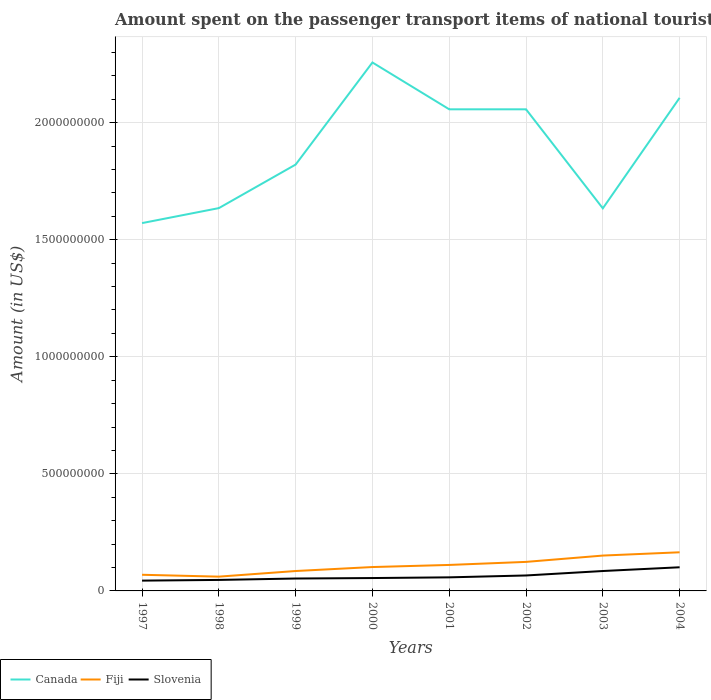How many different coloured lines are there?
Your answer should be very brief. 3. Does the line corresponding to Slovenia intersect with the line corresponding to Canada?
Ensure brevity in your answer.  No. Is the number of lines equal to the number of legend labels?
Give a very brief answer. Yes. Across all years, what is the maximum amount spent on the passenger transport items of national tourists in Canada?
Your response must be concise. 1.57e+09. What is the total amount spent on the passenger transport items of national tourists in Slovenia in the graph?
Provide a succinct answer. -4.30e+07. What is the difference between the highest and the second highest amount spent on the passenger transport items of national tourists in Slovenia?
Your response must be concise. 5.70e+07. What is the difference between the highest and the lowest amount spent on the passenger transport items of national tourists in Slovenia?
Provide a succinct answer. 3. Is the amount spent on the passenger transport items of national tourists in Canada strictly greater than the amount spent on the passenger transport items of national tourists in Fiji over the years?
Offer a very short reply. No. How many lines are there?
Offer a very short reply. 3. Are the values on the major ticks of Y-axis written in scientific E-notation?
Ensure brevity in your answer.  No. Where does the legend appear in the graph?
Offer a very short reply. Bottom left. How many legend labels are there?
Offer a very short reply. 3. What is the title of the graph?
Make the answer very short. Amount spent on the passenger transport items of national tourists. What is the label or title of the X-axis?
Give a very brief answer. Years. What is the Amount (in US$) in Canada in 1997?
Ensure brevity in your answer.  1.57e+09. What is the Amount (in US$) of Fiji in 1997?
Make the answer very short. 6.90e+07. What is the Amount (in US$) in Slovenia in 1997?
Offer a very short reply. 4.40e+07. What is the Amount (in US$) in Canada in 1998?
Your response must be concise. 1.64e+09. What is the Amount (in US$) in Fiji in 1998?
Give a very brief answer. 6.10e+07. What is the Amount (in US$) of Slovenia in 1998?
Give a very brief answer. 4.70e+07. What is the Amount (in US$) of Canada in 1999?
Make the answer very short. 1.82e+09. What is the Amount (in US$) of Fiji in 1999?
Your answer should be compact. 8.50e+07. What is the Amount (in US$) in Slovenia in 1999?
Offer a terse response. 5.30e+07. What is the Amount (in US$) in Canada in 2000?
Ensure brevity in your answer.  2.26e+09. What is the Amount (in US$) in Fiji in 2000?
Provide a short and direct response. 1.02e+08. What is the Amount (in US$) in Slovenia in 2000?
Provide a succinct answer. 5.50e+07. What is the Amount (in US$) in Canada in 2001?
Your answer should be compact. 2.06e+09. What is the Amount (in US$) in Fiji in 2001?
Your answer should be very brief. 1.11e+08. What is the Amount (in US$) in Slovenia in 2001?
Provide a short and direct response. 5.80e+07. What is the Amount (in US$) in Canada in 2002?
Provide a succinct answer. 2.06e+09. What is the Amount (in US$) of Fiji in 2002?
Your response must be concise. 1.24e+08. What is the Amount (in US$) in Slovenia in 2002?
Your answer should be compact. 6.60e+07. What is the Amount (in US$) of Canada in 2003?
Provide a short and direct response. 1.63e+09. What is the Amount (in US$) in Fiji in 2003?
Your answer should be compact. 1.51e+08. What is the Amount (in US$) in Slovenia in 2003?
Offer a very short reply. 8.50e+07. What is the Amount (in US$) in Canada in 2004?
Provide a succinct answer. 2.11e+09. What is the Amount (in US$) in Fiji in 2004?
Provide a short and direct response. 1.65e+08. What is the Amount (in US$) in Slovenia in 2004?
Offer a very short reply. 1.01e+08. Across all years, what is the maximum Amount (in US$) of Canada?
Keep it short and to the point. 2.26e+09. Across all years, what is the maximum Amount (in US$) of Fiji?
Ensure brevity in your answer.  1.65e+08. Across all years, what is the maximum Amount (in US$) in Slovenia?
Your answer should be very brief. 1.01e+08. Across all years, what is the minimum Amount (in US$) in Canada?
Provide a short and direct response. 1.57e+09. Across all years, what is the minimum Amount (in US$) of Fiji?
Offer a terse response. 6.10e+07. Across all years, what is the minimum Amount (in US$) in Slovenia?
Offer a terse response. 4.40e+07. What is the total Amount (in US$) of Canada in the graph?
Provide a short and direct response. 1.51e+1. What is the total Amount (in US$) in Fiji in the graph?
Provide a short and direct response. 8.68e+08. What is the total Amount (in US$) in Slovenia in the graph?
Offer a terse response. 5.09e+08. What is the difference between the Amount (in US$) of Canada in 1997 and that in 1998?
Offer a terse response. -6.40e+07. What is the difference between the Amount (in US$) of Fiji in 1997 and that in 1998?
Provide a short and direct response. 8.00e+06. What is the difference between the Amount (in US$) of Canada in 1997 and that in 1999?
Provide a short and direct response. -2.50e+08. What is the difference between the Amount (in US$) in Fiji in 1997 and that in 1999?
Your answer should be very brief. -1.60e+07. What is the difference between the Amount (in US$) in Slovenia in 1997 and that in 1999?
Offer a very short reply. -9.00e+06. What is the difference between the Amount (in US$) in Canada in 1997 and that in 2000?
Your response must be concise. -6.86e+08. What is the difference between the Amount (in US$) of Fiji in 1997 and that in 2000?
Make the answer very short. -3.30e+07. What is the difference between the Amount (in US$) in Slovenia in 1997 and that in 2000?
Your answer should be compact. -1.10e+07. What is the difference between the Amount (in US$) in Canada in 1997 and that in 2001?
Keep it short and to the point. -4.86e+08. What is the difference between the Amount (in US$) in Fiji in 1997 and that in 2001?
Your answer should be compact. -4.20e+07. What is the difference between the Amount (in US$) in Slovenia in 1997 and that in 2001?
Make the answer very short. -1.40e+07. What is the difference between the Amount (in US$) of Canada in 1997 and that in 2002?
Your answer should be compact. -4.86e+08. What is the difference between the Amount (in US$) of Fiji in 1997 and that in 2002?
Offer a terse response. -5.50e+07. What is the difference between the Amount (in US$) of Slovenia in 1997 and that in 2002?
Make the answer very short. -2.20e+07. What is the difference between the Amount (in US$) in Canada in 1997 and that in 2003?
Offer a very short reply. -6.30e+07. What is the difference between the Amount (in US$) in Fiji in 1997 and that in 2003?
Offer a terse response. -8.20e+07. What is the difference between the Amount (in US$) of Slovenia in 1997 and that in 2003?
Offer a terse response. -4.10e+07. What is the difference between the Amount (in US$) of Canada in 1997 and that in 2004?
Make the answer very short. -5.35e+08. What is the difference between the Amount (in US$) in Fiji in 1997 and that in 2004?
Make the answer very short. -9.60e+07. What is the difference between the Amount (in US$) of Slovenia in 1997 and that in 2004?
Give a very brief answer. -5.70e+07. What is the difference between the Amount (in US$) in Canada in 1998 and that in 1999?
Provide a succinct answer. -1.86e+08. What is the difference between the Amount (in US$) in Fiji in 1998 and that in 1999?
Your response must be concise. -2.40e+07. What is the difference between the Amount (in US$) in Slovenia in 1998 and that in 1999?
Your answer should be very brief. -6.00e+06. What is the difference between the Amount (in US$) in Canada in 1998 and that in 2000?
Your answer should be compact. -6.22e+08. What is the difference between the Amount (in US$) of Fiji in 1998 and that in 2000?
Your answer should be very brief. -4.10e+07. What is the difference between the Amount (in US$) in Slovenia in 1998 and that in 2000?
Offer a terse response. -8.00e+06. What is the difference between the Amount (in US$) in Canada in 1998 and that in 2001?
Your answer should be compact. -4.22e+08. What is the difference between the Amount (in US$) in Fiji in 1998 and that in 2001?
Provide a succinct answer. -5.00e+07. What is the difference between the Amount (in US$) of Slovenia in 1998 and that in 2001?
Offer a very short reply. -1.10e+07. What is the difference between the Amount (in US$) of Canada in 1998 and that in 2002?
Keep it short and to the point. -4.22e+08. What is the difference between the Amount (in US$) in Fiji in 1998 and that in 2002?
Make the answer very short. -6.30e+07. What is the difference between the Amount (in US$) of Slovenia in 1998 and that in 2002?
Ensure brevity in your answer.  -1.90e+07. What is the difference between the Amount (in US$) of Fiji in 1998 and that in 2003?
Offer a terse response. -9.00e+07. What is the difference between the Amount (in US$) in Slovenia in 1998 and that in 2003?
Your answer should be compact. -3.80e+07. What is the difference between the Amount (in US$) in Canada in 1998 and that in 2004?
Provide a short and direct response. -4.71e+08. What is the difference between the Amount (in US$) in Fiji in 1998 and that in 2004?
Your answer should be very brief. -1.04e+08. What is the difference between the Amount (in US$) in Slovenia in 1998 and that in 2004?
Provide a succinct answer. -5.40e+07. What is the difference between the Amount (in US$) in Canada in 1999 and that in 2000?
Ensure brevity in your answer.  -4.36e+08. What is the difference between the Amount (in US$) of Fiji in 1999 and that in 2000?
Offer a terse response. -1.70e+07. What is the difference between the Amount (in US$) in Canada in 1999 and that in 2001?
Provide a short and direct response. -2.36e+08. What is the difference between the Amount (in US$) in Fiji in 1999 and that in 2001?
Your answer should be very brief. -2.60e+07. What is the difference between the Amount (in US$) of Slovenia in 1999 and that in 2001?
Your answer should be very brief. -5.00e+06. What is the difference between the Amount (in US$) in Canada in 1999 and that in 2002?
Offer a terse response. -2.36e+08. What is the difference between the Amount (in US$) in Fiji in 1999 and that in 2002?
Provide a succinct answer. -3.90e+07. What is the difference between the Amount (in US$) of Slovenia in 1999 and that in 2002?
Your answer should be compact. -1.30e+07. What is the difference between the Amount (in US$) in Canada in 1999 and that in 2003?
Keep it short and to the point. 1.87e+08. What is the difference between the Amount (in US$) in Fiji in 1999 and that in 2003?
Provide a succinct answer. -6.60e+07. What is the difference between the Amount (in US$) in Slovenia in 1999 and that in 2003?
Your answer should be very brief. -3.20e+07. What is the difference between the Amount (in US$) of Canada in 1999 and that in 2004?
Make the answer very short. -2.85e+08. What is the difference between the Amount (in US$) of Fiji in 1999 and that in 2004?
Give a very brief answer. -8.00e+07. What is the difference between the Amount (in US$) of Slovenia in 1999 and that in 2004?
Offer a very short reply. -4.80e+07. What is the difference between the Amount (in US$) in Canada in 2000 and that in 2001?
Provide a succinct answer. 2.00e+08. What is the difference between the Amount (in US$) in Fiji in 2000 and that in 2001?
Your answer should be very brief. -9.00e+06. What is the difference between the Amount (in US$) in Fiji in 2000 and that in 2002?
Keep it short and to the point. -2.20e+07. What is the difference between the Amount (in US$) in Slovenia in 2000 and that in 2002?
Provide a short and direct response. -1.10e+07. What is the difference between the Amount (in US$) in Canada in 2000 and that in 2003?
Provide a short and direct response. 6.23e+08. What is the difference between the Amount (in US$) in Fiji in 2000 and that in 2003?
Offer a terse response. -4.90e+07. What is the difference between the Amount (in US$) in Slovenia in 2000 and that in 2003?
Offer a very short reply. -3.00e+07. What is the difference between the Amount (in US$) of Canada in 2000 and that in 2004?
Offer a terse response. 1.51e+08. What is the difference between the Amount (in US$) of Fiji in 2000 and that in 2004?
Offer a terse response. -6.30e+07. What is the difference between the Amount (in US$) in Slovenia in 2000 and that in 2004?
Make the answer very short. -4.60e+07. What is the difference between the Amount (in US$) of Canada in 2001 and that in 2002?
Your answer should be compact. 0. What is the difference between the Amount (in US$) of Fiji in 2001 and that in 2002?
Keep it short and to the point. -1.30e+07. What is the difference between the Amount (in US$) in Slovenia in 2001 and that in 2002?
Make the answer very short. -8.00e+06. What is the difference between the Amount (in US$) in Canada in 2001 and that in 2003?
Offer a terse response. 4.23e+08. What is the difference between the Amount (in US$) in Fiji in 2001 and that in 2003?
Provide a short and direct response. -4.00e+07. What is the difference between the Amount (in US$) in Slovenia in 2001 and that in 2003?
Provide a succinct answer. -2.70e+07. What is the difference between the Amount (in US$) in Canada in 2001 and that in 2004?
Make the answer very short. -4.90e+07. What is the difference between the Amount (in US$) of Fiji in 2001 and that in 2004?
Your answer should be compact. -5.40e+07. What is the difference between the Amount (in US$) of Slovenia in 2001 and that in 2004?
Ensure brevity in your answer.  -4.30e+07. What is the difference between the Amount (in US$) of Canada in 2002 and that in 2003?
Give a very brief answer. 4.23e+08. What is the difference between the Amount (in US$) in Fiji in 2002 and that in 2003?
Give a very brief answer. -2.70e+07. What is the difference between the Amount (in US$) in Slovenia in 2002 and that in 2003?
Ensure brevity in your answer.  -1.90e+07. What is the difference between the Amount (in US$) of Canada in 2002 and that in 2004?
Offer a very short reply. -4.90e+07. What is the difference between the Amount (in US$) in Fiji in 2002 and that in 2004?
Offer a very short reply. -4.10e+07. What is the difference between the Amount (in US$) of Slovenia in 2002 and that in 2004?
Keep it short and to the point. -3.50e+07. What is the difference between the Amount (in US$) in Canada in 2003 and that in 2004?
Ensure brevity in your answer.  -4.72e+08. What is the difference between the Amount (in US$) in Fiji in 2003 and that in 2004?
Your response must be concise. -1.40e+07. What is the difference between the Amount (in US$) in Slovenia in 2003 and that in 2004?
Give a very brief answer. -1.60e+07. What is the difference between the Amount (in US$) in Canada in 1997 and the Amount (in US$) in Fiji in 1998?
Offer a terse response. 1.51e+09. What is the difference between the Amount (in US$) of Canada in 1997 and the Amount (in US$) of Slovenia in 1998?
Provide a succinct answer. 1.52e+09. What is the difference between the Amount (in US$) of Fiji in 1997 and the Amount (in US$) of Slovenia in 1998?
Your response must be concise. 2.20e+07. What is the difference between the Amount (in US$) of Canada in 1997 and the Amount (in US$) of Fiji in 1999?
Ensure brevity in your answer.  1.49e+09. What is the difference between the Amount (in US$) of Canada in 1997 and the Amount (in US$) of Slovenia in 1999?
Give a very brief answer. 1.52e+09. What is the difference between the Amount (in US$) in Fiji in 1997 and the Amount (in US$) in Slovenia in 1999?
Make the answer very short. 1.60e+07. What is the difference between the Amount (in US$) in Canada in 1997 and the Amount (in US$) in Fiji in 2000?
Make the answer very short. 1.47e+09. What is the difference between the Amount (in US$) of Canada in 1997 and the Amount (in US$) of Slovenia in 2000?
Ensure brevity in your answer.  1.52e+09. What is the difference between the Amount (in US$) of Fiji in 1997 and the Amount (in US$) of Slovenia in 2000?
Provide a short and direct response. 1.40e+07. What is the difference between the Amount (in US$) of Canada in 1997 and the Amount (in US$) of Fiji in 2001?
Keep it short and to the point. 1.46e+09. What is the difference between the Amount (in US$) in Canada in 1997 and the Amount (in US$) in Slovenia in 2001?
Offer a terse response. 1.51e+09. What is the difference between the Amount (in US$) of Fiji in 1997 and the Amount (in US$) of Slovenia in 2001?
Offer a very short reply. 1.10e+07. What is the difference between the Amount (in US$) in Canada in 1997 and the Amount (in US$) in Fiji in 2002?
Offer a very short reply. 1.45e+09. What is the difference between the Amount (in US$) in Canada in 1997 and the Amount (in US$) in Slovenia in 2002?
Your answer should be very brief. 1.50e+09. What is the difference between the Amount (in US$) of Fiji in 1997 and the Amount (in US$) of Slovenia in 2002?
Make the answer very short. 3.00e+06. What is the difference between the Amount (in US$) in Canada in 1997 and the Amount (in US$) in Fiji in 2003?
Provide a short and direct response. 1.42e+09. What is the difference between the Amount (in US$) of Canada in 1997 and the Amount (in US$) of Slovenia in 2003?
Provide a short and direct response. 1.49e+09. What is the difference between the Amount (in US$) of Fiji in 1997 and the Amount (in US$) of Slovenia in 2003?
Your response must be concise. -1.60e+07. What is the difference between the Amount (in US$) of Canada in 1997 and the Amount (in US$) of Fiji in 2004?
Ensure brevity in your answer.  1.41e+09. What is the difference between the Amount (in US$) of Canada in 1997 and the Amount (in US$) of Slovenia in 2004?
Your answer should be compact. 1.47e+09. What is the difference between the Amount (in US$) in Fiji in 1997 and the Amount (in US$) in Slovenia in 2004?
Make the answer very short. -3.20e+07. What is the difference between the Amount (in US$) of Canada in 1998 and the Amount (in US$) of Fiji in 1999?
Provide a succinct answer. 1.55e+09. What is the difference between the Amount (in US$) in Canada in 1998 and the Amount (in US$) in Slovenia in 1999?
Give a very brief answer. 1.58e+09. What is the difference between the Amount (in US$) of Fiji in 1998 and the Amount (in US$) of Slovenia in 1999?
Your response must be concise. 8.00e+06. What is the difference between the Amount (in US$) in Canada in 1998 and the Amount (in US$) in Fiji in 2000?
Ensure brevity in your answer.  1.53e+09. What is the difference between the Amount (in US$) in Canada in 1998 and the Amount (in US$) in Slovenia in 2000?
Your answer should be very brief. 1.58e+09. What is the difference between the Amount (in US$) in Canada in 1998 and the Amount (in US$) in Fiji in 2001?
Your response must be concise. 1.52e+09. What is the difference between the Amount (in US$) in Canada in 1998 and the Amount (in US$) in Slovenia in 2001?
Provide a short and direct response. 1.58e+09. What is the difference between the Amount (in US$) of Canada in 1998 and the Amount (in US$) of Fiji in 2002?
Your response must be concise. 1.51e+09. What is the difference between the Amount (in US$) in Canada in 1998 and the Amount (in US$) in Slovenia in 2002?
Provide a succinct answer. 1.57e+09. What is the difference between the Amount (in US$) of Fiji in 1998 and the Amount (in US$) of Slovenia in 2002?
Make the answer very short. -5.00e+06. What is the difference between the Amount (in US$) of Canada in 1998 and the Amount (in US$) of Fiji in 2003?
Make the answer very short. 1.48e+09. What is the difference between the Amount (in US$) of Canada in 1998 and the Amount (in US$) of Slovenia in 2003?
Ensure brevity in your answer.  1.55e+09. What is the difference between the Amount (in US$) in Fiji in 1998 and the Amount (in US$) in Slovenia in 2003?
Provide a short and direct response. -2.40e+07. What is the difference between the Amount (in US$) of Canada in 1998 and the Amount (in US$) of Fiji in 2004?
Provide a succinct answer. 1.47e+09. What is the difference between the Amount (in US$) in Canada in 1998 and the Amount (in US$) in Slovenia in 2004?
Give a very brief answer. 1.53e+09. What is the difference between the Amount (in US$) in Fiji in 1998 and the Amount (in US$) in Slovenia in 2004?
Offer a very short reply. -4.00e+07. What is the difference between the Amount (in US$) of Canada in 1999 and the Amount (in US$) of Fiji in 2000?
Your response must be concise. 1.72e+09. What is the difference between the Amount (in US$) in Canada in 1999 and the Amount (in US$) in Slovenia in 2000?
Give a very brief answer. 1.77e+09. What is the difference between the Amount (in US$) of Fiji in 1999 and the Amount (in US$) of Slovenia in 2000?
Make the answer very short. 3.00e+07. What is the difference between the Amount (in US$) of Canada in 1999 and the Amount (in US$) of Fiji in 2001?
Provide a succinct answer. 1.71e+09. What is the difference between the Amount (in US$) in Canada in 1999 and the Amount (in US$) in Slovenia in 2001?
Give a very brief answer. 1.76e+09. What is the difference between the Amount (in US$) of Fiji in 1999 and the Amount (in US$) of Slovenia in 2001?
Offer a terse response. 2.70e+07. What is the difference between the Amount (in US$) of Canada in 1999 and the Amount (in US$) of Fiji in 2002?
Make the answer very short. 1.70e+09. What is the difference between the Amount (in US$) in Canada in 1999 and the Amount (in US$) in Slovenia in 2002?
Ensure brevity in your answer.  1.76e+09. What is the difference between the Amount (in US$) of Fiji in 1999 and the Amount (in US$) of Slovenia in 2002?
Offer a terse response. 1.90e+07. What is the difference between the Amount (in US$) of Canada in 1999 and the Amount (in US$) of Fiji in 2003?
Offer a terse response. 1.67e+09. What is the difference between the Amount (in US$) of Canada in 1999 and the Amount (in US$) of Slovenia in 2003?
Make the answer very short. 1.74e+09. What is the difference between the Amount (in US$) in Fiji in 1999 and the Amount (in US$) in Slovenia in 2003?
Your response must be concise. 0. What is the difference between the Amount (in US$) in Canada in 1999 and the Amount (in US$) in Fiji in 2004?
Provide a succinct answer. 1.66e+09. What is the difference between the Amount (in US$) of Canada in 1999 and the Amount (in US$) of Slovenia in 2004?
Your answer should be very brief. 1.72e+09. What is the difference between the Amount (in US$) of Fiji in 1999 and the Amount (in US$) of Slovenia in 2004?
Provide a succinct answer. -1.60e+07. What is the difference between the Amount (in US$) in Canada in 2000 and the Amount (in US$) in Fiji in 2001?
Keep it short and to the point. 2.15e+09. What is the difference between the Amount (in US$) of Canada in 2000 and the Amount (in US$) of Slovenia in 2001?
Your response must be concise. 2.20e+09. What is the difference between the Amount (in US$) of Fiji in 2000 and the Amount (in US$) of Slovenia in 2001?
Keep it short and to the point. 4.40e+07. What is the difference between the Amount (in US$) of Canada in 2000 and the Amount (in US$) of Fiji in 2002?
Ensure brevity in your answer.  2.13e+09. What is the difference between the Amount (in US$) of Canada in 2000 and the Amount (in US$) of Slovenia in 2002?
Provide a short and direct response. 2.19e+09. What is the difference between the Amount (in US$) in Fiji in 2000 and the Amount (in US$) in Slovenia in 2002?
Offer a very short reply. 3.60e+07. What is the difference between the Amount (in US$) in Canada in 2000 and the Amount (in US$) in Fiji in 2003?
Provide a short and direct response. 2.11e+09. What is the difference between the Amount (in US$) in Canada in 2000 and the Amount (in US$) in Slovenia in 2003?
Your response must be concise. 2.17e+09. What is the difference between the Amount (in US$) in Fiji in 2000 and the Amount (in US$) in Slovenia in 2003?
Ensure brevity in your answer.  1.70e+07. What is the difference between the Amount (in US$) of Canada in 2000 and the Amount (in US$) of Fiji in 2004?
Give a very brief answer. 2.09e+09. What is the difference between the Amount (in US$) of Canada in 2000 and the Amount (in US$) of Slovenia in 2004?
Your answer should be compact. 2.16e+09. What is the difference between the Amount (in US$) of Fiji in 2000 and the Amount (in US$) of Slovenia in 2004?
Provide a succinct answer. 1.00e+06. What is the difference between the Amount (in US$) of Canada in 2001 and the Amount (in US$) of Fiji in 2002?
Your answer should be compact. 1.93e+09. What is the difference between the Amount (in US$) of Canada in 2001 and the Amount (in US$) of Slovenia in 2002?
Ensure brevity in your answer.  1.99e+09. What is the difference between the Amount (in US$) in Fiji in 2001 and the Amount (in US$) in Slovenia in 2002?
Your answer should be very brief. 4.50e+07. What is the difference between the Amount (in US$) of Canada in 2001 and the Amount (in US$) of Fiji in 2003?
Provide a short and direct response. 1.91e+09. What is the difference between the Amount (in US$) of Canada in 2001 and the Amount (in US$) of Slovenia in 2003?
Give a very brief answer. 1.97e+09. What is the difference between the Amount (in US$) in Fiji in 2001 and the Amount (in US$) in Slovenia in 2003?
Make the answer very short. 2.60e+07. What is the difference between the Amount (in US$) in Canada in 2001 and the Amount (in US$) in Fiji in 2004?
Your answer should be compact. 1.89e+09. What is the difference between the Amount (in US$) in Canada in 2001 and the Amount (in US$) in Slovenia in 2004?
Ensure brevity in your answer.  1.96e+09. What is the difference between the Amount (in US$) in Canada in 2002 and the Amount (in US$) in Fiji in 2003?
Your answer should be very brief. 1.91e+09. What is the difference between the Amount (in US$) of Canada in 2002 and the Amount (in US$) of Slovenia in 2003?
Your answer should be very brief. 1.97e+09. What is the difference between the Amount (in US$) in Fiji in 2002 and the Amount (in US$) in Slovenia in 2003?
Your response must be concise. 3.90e+07. What is the difference between the Amount (in US$) of Canada in 2002 and the Amount (in US$) of Fiji in 2004?
Your response must be concise. 1.89e+09. What is the difference between the Amount (in US$) in Canada in 2002 and the Amount (in US$) in Slovenia in 2004?
Offer a terse response. 1.96e+09. What is the difference between the Amount (in US$) of Fiji in 2002 and the Amount (in US$) of Slovenia in 2004?
Your answer should be compact. 2.30e+07. What is the difference between the Amount (in US$) of Canada in 2003 and the Amount (in US$) of Fiji in 2004?
Your answer should be very brief. 1.47e+09. What is the difference between the Amount (in US$) in Canada in 2003 and the Amount (in US$) in Slovenia in 2004?
Keep it short and to the point. 1.53e+09. What is the difference between the Amount (in US$) of Fiji in 2003 and the Amount (in US$) of Slovenia in 2004?
Keep it short and to the point. 5.00e+07. What is the average Amount (in US$) of Canada per year?
Offer a terse response. 1.89e+09. What is the average Amount (in US$) in Fiji per year?
Provide a succinct answer. 1.08e+08. What is the average Amount (in US$) of Slovenia per year?
Give a very brief answer. 6.36e+07. In the year 1997, what is the difference between the Amount (in US$) in Canada and Amount (in US$) in Fiji?
Give a very brief answer. 1.50e+09. In the year 1997, what is the difference between the Amount (in US$) of Canada and Amount (in US$) of Slovenia?
Provide a succinct answer. 1.53e+09. In the year 1997, what is the difference between the Amount (in US$) of Fiji and Amount (in US$) of Slovenia?
Ensure brevity in your answer.  2.50e+07. In the year 1998, what is the difference between the Amount (in US$) in Canada and Amount (in US$) in Fiji?
Make the answer very short. 1.57e+09. In the year 1998, what is the difference between the Amount (in US$) of Canada and Amount (in US$) of Slovenia?
Offer a very short reply. 1.59e+09. In the year 1998, what is the difference between the Amount (in US$) in Fiji and Amount (in US$) in Slovenia?
Offer a very short reply. 1.40e+07. In the year 1999, what is the difference between the Amount (in US$) of Canada and Amount (in US$) of Fiji?
Provide a succinct answer. 1.74e+09. In the year 1999, what is the difference between the Amount (in US$) of Canada and Amount (in US$) of Slovenia?
Your answer should be very brief. 1.77e+09. In the year 1999, what is the difference between the Amount (in US$) of Fiji and Amount (in US$) of Slovenia?
Offer a very short reply. 3.20e+07. In the year 2000, what is the difference between the Amount (in US$) in Canada and Amount (in US$) in Fiji?
Offer a very short reply. 2.16e+09. In the year 2000, what is the difference between the Amount (in US$) of Canada and Amount (in US$) of Slovenia?
Your answer should be very brief. 2.20e+09. In the year 2000, what is the difference between the Amount (in US$) of Fiji and Amount (in US$) of Slovenia?
Provide a succinct answer. 4.70e+07. In the year 2001, what is the difference between the Amount (in US$) in Canada and Amount (in US$) in Fiji?
Keep it short and to the point. 1.95e+09. In the year 2001, what is the difference between the Amount (in US$) in Canada and Amount (in US$) in Slovenia?
Offer a terse response. 2.00e+09. In the year 2001, what is the difference between the Amount (in US$) of Fiji and Amount (in US$) of Slovenia?
Ensure brevity in your answer.  5.30e+07. In the year 2002, what is the difference between the Amount (in US$) of Canada and Amount (in US$) of Fiji?
Provide a short and direct response. 1.93e+09. In the year 2002, what is the difference between the Amount (in US$) in Canada and Amount (in US$) in Slovenia?
Keep it short and to the point. 1.99e+09. In the year 2002, what is the difference between the Amount (in US$) of Fiji and Amount (in US$) of Slovenia?
Your answer should be compact. 5.80e+07. In the year 2003, what is the difference between the Amount (in US$) of Canada and Amount (in US$) of Fiji?
Offer a very short reply. 1.48e+09. In the year 2003, what is the difference between the Amount (in US$) in Canada and Amount (in US$) in Slovenia?
Make the answer very short. 1.55e+09. In the year 2003, what is the difference between the Amount (in US$) in Fiji and Amount (in US$) in Slovenia?
Keep it short and to the point. 6.60e+07. In the year 2004, what is the difference between the Amount (in US$) in Canada and Amount (in US$) in Fiji?
Provide a succinct answer. 1.94e+09. In the year 2004, what is the difference between the Amount (in US$) of Canada and Amount (in US$) of Slovenia?
Provide a succinct answer. 2.00e+09. In the year 2004, what is the difference between the Amount (in US$) of Fiji and Amount (in US$) of Slovenia?
Give a very brief answer. 6.40e+07. What is the ratio of the Amount (in US$) of Canada in 1997 to that in 1998?
Your response must be concise. 0.96. What is the ratio of the Amount (in US$) in Fiji in 1997 to that in 1998?
Provide a succinct answer. 1.13. What is the ratio of the Amount (in US$) in Slovenia in 1997 to that in 1998?
Keep it short and to the point. 0.94. What is the ratio of the Amount (in US$) of Canada in 1997 to that in 1999?
Offer a terse response. 0.86. What is the ratio of the Amount (in US$) in Fiji in 1997 to that in 1999?
Your answer should be compact. 0.81. What is the ratio of the Amount (in US$) of Slovenia in 1997 to that in 1999?
Offer a terse response. 0.83. What is the ratio of the Amount (in US$) in Canada in 1997 to that in 2000?
Make the answer very short. 0.7. What is the ratio of the Amount (in US$) of Fiji in 1997 to that in 2000?
Ensure brevity in your answer.  0.68. What is the ratio of the Amount (in US$) of Canada in 1997 to that in 2001?
Offer a terse response. 0.76. What is the ratio of the Amount (in US$) of Fiji in 1997 to that in 2001?
Your response must be concise. 0.62. What is the ratio of the Amount (in US$) in Slovenia in 1997 to that in 2001?
Give a very brief answer. 0.76. What is the ratio of the Amount (in US$) of Canada in 1997 to that in 2002?
Keep it short and to the point. 0.76. What is the ratio of the Amount (in US$) of Fiji in 1997 to that in 2002?
Make the answer very short. 0.56. What is the ratio of the Amount (in US$) of Slovenia in 1997 to that in 2002?
Give a very brief answer. 0.67. What is the ratio of the Amount (in US$) of Canada in 1997 to that in 2003?
Make the answer very short. 0.96. What is the ratio of the Amount (in US$) in Fiji in 1997 to that in 2003?
Make the answer very short. 0.46. What is the ratio of the Amount (in US$) in Slovenia in 1997 to that in 2003?
Offer a very short reply. 0.52. What is the ratio of the Amount (in US$) of Canada in 1997 to that in 2004?
Offer a terse response. 0.75. What is the ratio of the Amount (in US$) in Fiji in 1997 to that in 2004?
Offer a terse response. 0.42. What is the ratio of the Amount (in US$) of Slovenia in 1997 to that in 2004?
Your response must be concise. 0.44. What is the ratio of the Amount (in US$) of Canada in 1998 to that in 1999?
Your response must be concise. 0.9. What is the ratio of the Amount (in US$) in Fiji in 1998 to that in 1999?
Provide a succinct answer. 0.72. What is the ratio of the Amount (in US$) in Slovenia in 1998 to that in 1999?
Make the answer very short. 0.89. What is the ratio of the Amount (in US$) in Canada in 1998 to that in 2000?
Your answer should be compact. 0.72. What is the ratio of the Amount (in US$) of Fiji in 1998 to that in 2000?
Your answer should be compact. 0.6. What is the ratio of the Amount (in US$) in Slovenia in 1998 to that in 2000?
Offer a very short reply. 0.85. What is the ratio of the Amount (in US$) of Canada in 1998 to that in 2001?
Your response must be concise. 0.79. What is the ratio of the Amount (in US$) in Fiji in 1998 to that in 2001?
Your answer should be compact. 0.55. What is the ratio of the Amount (in US$) of Slovenia in 1998 to that in 2001?
Provide a succinct answer. 0.81. What is the ratio of the Amount (in US$) in Canada in 1998 to that in 2002?
Give a very brief answer. 0.79. What is the ratio of the Amount (in US$) in Fiji in 1998 to that in 2002?
Give a very brief answer. 0.49. What is the ratio of the Amount (in US$) of Slovenia in 1998 to that in 2002?
Keep it short and to the point. 0.71. What is the ratio of the Amount (in US$) of Fiji in 1998 to that in 2003?
Provide a short and direct response. 0.4. What is the ratio of the Amount (in US$) of Slovenia in 1998 to that in 2003?
Make the answer very short. 0.55. What is the ratio of the Amount (in US$) in Canada in 1998 to that in 2004?
Offer a terse response. 0.78. What is the ratio of the Amount (in US$) in Fiji in 1998 to that in 2004?
Give a very brief answer. 0.37. What is the ratio of the Amount (in US$) in Slovenia in 1998 to that in 2004?
Offer a terse response. 0.47. What is the ratio of the Amount (in US$) in Canada in 1999 to that in 2000?
Offer a very short reply. 0.81. What is the ratio of the Amount (in US$) in Fiji in 1999 to that in 2000?
Provide a succinct answer. 0.83. What is the ratio of the Amount (in US$) in Slovenia in 1999 to that in 2000?
Provide a succinct answer. 0.96. What is the ratio of the Amount (in US$) of Canada in 1999 to that in 2001?
Offer a terse response. 0.89. What is the ratio of the Amount (in US$) in Fiji in 1999 to that in 2001?
Keep it short and to the point. 0.77. What is the ratio of the Amount (in US$) in Slovenia in 1999 to that in 2001?
Ensure brevity in your answer.  0.91. What is the ratio of the Amount (in US$) of Canada in 1999 to that in 2002?
Offer a terse response. 0.89. What is the ratio of the Amount (in US$) in Fiji in 1999 to that in 2002?
Provide a succinct answer. 0.69. What is the ratio of the Amount (in US$) of Slovenia in 1999 to that in 2002?
Provide a succinct answer. 0.8. What is the ratio of the Amount (in US$) in Canada in 1999 to that in 2003?
Offer a very short reply. 1.11. What is the ratio of the Amount (in US$) of Fiji in 1999 to that in 2003?
Provide a short and direct response. 0.56. What is the ratio of the Amount (in US$) of Slovenia in 1999 to that in 2003?
Provide a succinct answer. 0.62. What is the ratio of the Amount (in US$) in Canada in 1999 to that in 2004?
Give a very brief answer. 0.86. What is the ratio of the Amount (in US$) in Fiji in 1999 to that in 2004?
Your answer should be compact. 0.52. What is the ratio of the Amount (in US$) in Slovenia in 1999 to that in 2004?
Make the answer very short. 0.52. What is the ratio of the Amount (in US$) in Canada in 2000 to that in 2001?
Offer a very short reply. 1.1. What is the ratio of the Amount (in US$) of Fiji in 2000 to that in 2001?
Your answer should be very brief. 0.92. What is the ratio of the Amount (in US$) in Slovenia in 2000 to that in 2001?
Offer a terse response. 0.95. What is the ratio of the Amount (in US$) of Canada in 2000 to that in 2002?
Your answer should be compact. 1.1. What is the ratio of the Amount (in US$) in Fiji in 2000 to that in 2002?
Ensure brevity in your answer.  0.82. What is the ratio of the Amount (in US$) in Canada in 2000 to that in 2003?
Offer a terse response. 1.38. What is the ratio of the Amount (in US$) of Fiji in 2000 to that in 2003?
Your answer should be compact. 0.68. What is the ratio of the Amount (in US$) of Slovenia in 2000 to that in 2003?
Give a very brief answer. 0.65. What is the ratio of the Amount (in US$) of Canada in 2000 to that in 2004?
Keep it short and to the point. 1.07. What is the ratio of the Amount (in US$) of Fiji in 2000 to that in 2004?
Give a very brief answer. 0.62. What is the ratio of the Amount (in US$) in Slovenia in 2000 to that in 2004?
Keep it short and to the point. 0.54. What is the ratio of the Amount (in US$) in Fiji in 2001 to that in 2002?
Your answer should be very brief. 0.9. What is the ratio of the Amount (in US$) in Slovenia in 2001 to that in 2002?
Offer a terse response. 0.88. What is the ratio of the Amount (in US$) of Canada in 2001 to that in 2003?
Offer a terse response. 1.26. What is the ratio of the Amount (in US$) in Fiji in 2001 to that in 2003?
Give a very brief answer. 0.74. What is the ratio of the Amount (in US$) in Slovenia in 2001 to that in 2003?
Your answer should be compact. 0.68. What is the ratio of the Amount (in US$) of Canada in 2001 to that in 2004?
Offer a very short reply. 0.98. What is the ratio of the Amount (in US$) of Fiji in 2001 to that in 2004?
Your answer should be very brief. 0.67. What is the ratio of the Amount (in US$) in Slovenia in 2001 to that in 2004?
Provide a short and direct response. 0.57. What is the ratio of the Amount (in US$) in Canada in 2002 to that in 2003?
Give a very brief answer. 1.26. What is the ratio of the Amount (in US$) of Fiji in 2002 to that in 2003?
Your response must be concise. 0.82. What is the ratio of the Amount (in US$) in Slovenia in 2002 to that in 2003?
Provide a succinct answer. 0.78. What is the ratio of the Amount (in US$) in Canada in 2002 to that in 2004?
Give a very brief answer. 0.98. What is the ratio of the Amount (in US$) in Fiji in 2002 to that in 2004?
Offer a very short reply. 0.75. What is the ratio of the Amount (in US$) of Slovenia in 2002 to that in 2004?
Make the answer very short. 0.65. What is the ratio of the Amount (in US$) in Canada in 2003 to that in 2004?
Offer a terse response. 0.78. What is the ratio of the Amount (in US$) of Fiji in 2003 to that in 2004?
Offer a terse response. 0.92. What is the ratio of the Amount (in US$) in Slovenia in 2003 to that in 2004?
Ensure brevity in your answer.  0.84. What is the difference between the highest and the second highest Amount (in US$) of Canada?
Make the answer very short. 1.51e+08. What is the difference between the highest and the second highest Amount (in US$) in Fiji?
Offer a terse response. 1.40e+07. What is the difference between the highest and the second highest Amount (in US$) in Slovenia?
Your answer should be compact. 1.60e+07. What is the difference between the highest and the lowest Amount (in US$) of Canada?
Provide a short and direct response. 6.86e+08. What is the difference between the highest and the lowest Amount (in US$) in Fiji?
Ensure brevity in your answer.  1.04e+08. What is the difference between the highest and the lowest Amount (in US$) in Slovenia?
Your response must be concise. 5.70e+07. 